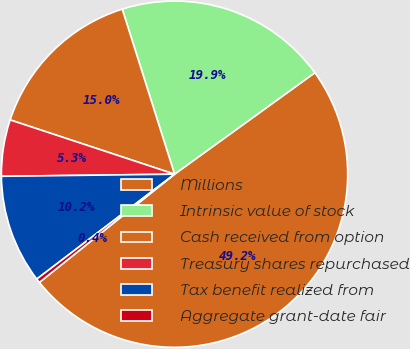<chart> <loc_0><loc_0><loc_500><loc_500><pie_chart><fcel>Millions<fcel>Intrinsic value of stock<fcel>Cash received from option<fcel>Treasury shares repurchased<fcel>Tax benefit realized from<fcel>Aggregate grant-date fair<nl><fcel>49.22%<fcel>19.92%<fcel>15.04%<fcel>5.27%<fcel>10.16%<fcel>0.39%<nl></chart> 